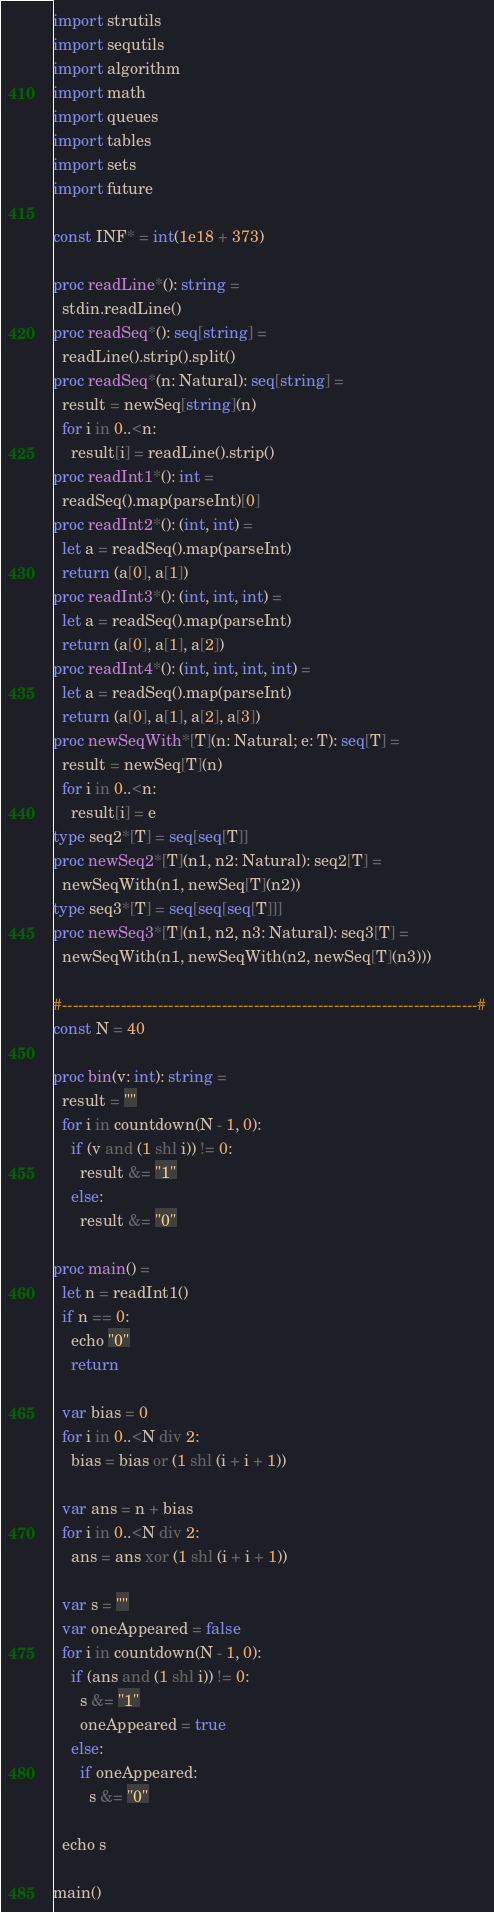Convert code to text. <code><loc_0><loc_0><loc_500><loc_500><_Nim_>import strutils
import sequtils
import algorithm
import math
import queues
import tables
import sets
import future

const INF* = int(1e18 + 373)

proc readLine*(): string =
  stdin.readLine()
proc readSeq*(): seq[string] =
  readLine().strip().split()
proc readSeq*(n: Natural): seq[string] =
  result = newSeq[string](n)
  for i in 0..<n:
    result[i] = readLine().strip()
proc readInt1*(): int =
  readSeq().map(parseInt)[0]
proc readInt2*(): (int, int) =
  let a = readSeq().map(parseInt)
  return (a[0], a[1])
proc readInt3*(): (int, int, int) =
  let a = readSeq().map(parseInt)
  return (a[0], a[1], a[2])
proc readInt4*(): (int, int, int, int) =
  let a = readSeq().map(parseInt)
  return (a[0], a[1], a[2], a[3])
proc newSeqWith*[T](n: Natural; e: T): seq[T] =
  result = newSeq[T](n)
  for i in 0..<n:
    result[i] = e
type seq2*[T] = seq[seq[T]]
proc newSeq2*[T](n1, n2: Natural): seq2[T] =
  newSeqWith(n1, newSeq[T](n2))
type seq3*[T] = seq[seq[seq[T]]]
proc newSeq3*[T](n1, n2, n3: Natural): seq3[T] =
  newSeqWith(n1, newSeqWith(n2, newSeq[T](n3)))

#------------------------------------------------------------------------------#
const N = 40

proc bin(v: int): string =
  result = ""
  for i in countdown(N - 1, 0):
    if (v and (1 shl i)) != 0:
      result &= "1"
    else:
      result &= "0"

proc main() =
  let n = readInt1()
  if n == 0:
    echo "0"
    return

  var bias = 0
  for i in 0..<N div 2:
    bias = bias or (1 shl (i + i + 1))

  var ans = n + bias
  for i in 0..<N div 2:
    ans = ans xor (1 shl (i + i + 1))

  var s = ""
  var oneAppeared = false
  for i in countdown(N - 1, 0):
    if (ans and (1 shl i)) != 0:
      s &= "1"
      oneAppeared = true
    else:
      if oneAppeared:
        s &= "0"

  echo s

main()

</code> 